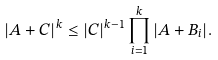Convert formula to latex. <formula><loc_0><loc_0><loc_500><loc_500>| A + C | ^ { k } \leq | C | ^ { k - 1 } \prod _ { i = 1 } ^ { k } | A + B _ { i } | .</formula> 